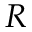Convert formula to latex. <formula><loc_0><loc_0><loc_500><loc_500>R</formula> 